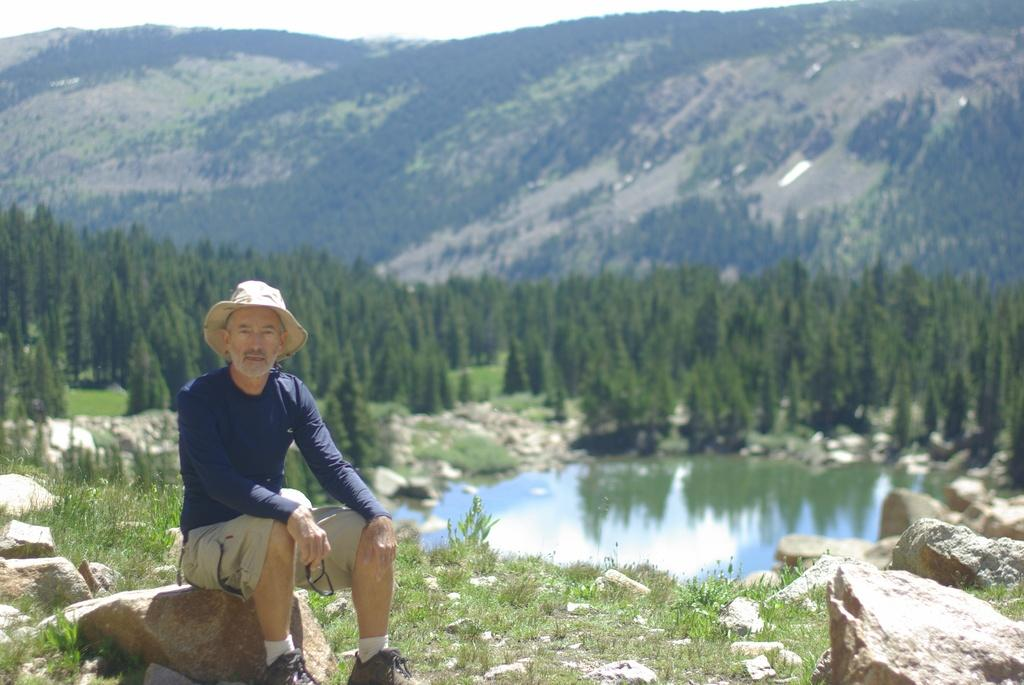What is the man in the image doing? The man is sitting on a rock in the image. Where is the rock located? The rock is on the ground. What can be seen in the background of the image? There is sky, hills, trees, stones on the grass, and a pond visible in the background of the image. What is the ground like in the image? The ground is visible in the image. What type of marble is the man playing with in the image? There is no marble present in the image; the man is sitting on a rock. How many snails can be seen crawling on the man's shoes in the image? There are no snails visible in the image. 